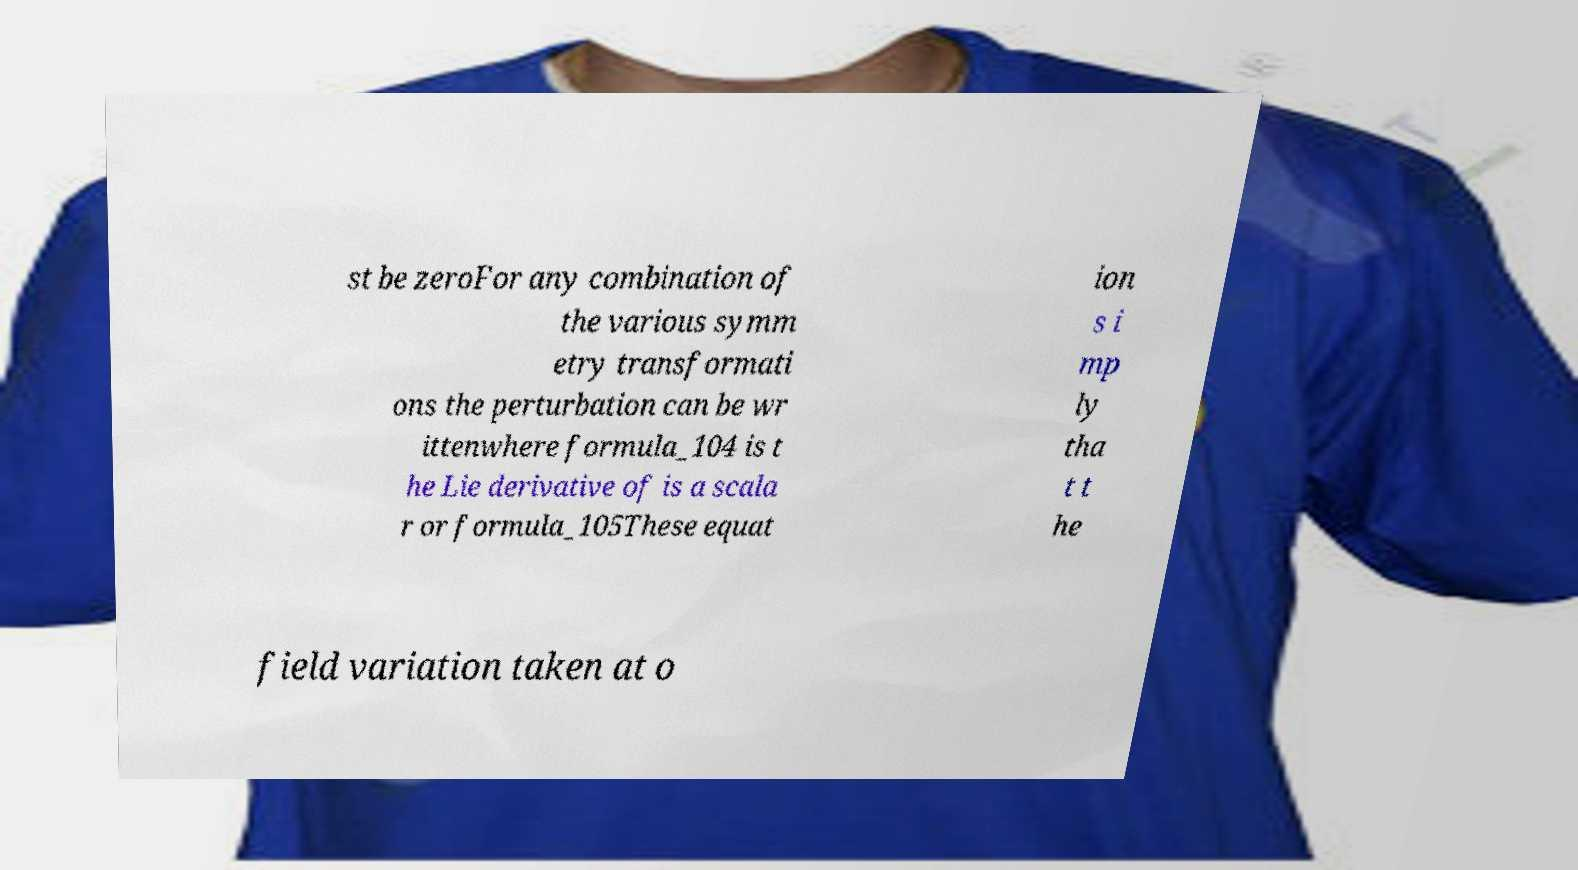Please identify and transcribe the text found in this image. st be zeroFor any combination of the various symm etry transformati ons the perturbation can be wr ittenwhere formula_104 is t he Lie derivative of is a scala r or formula_105These equat ion s i mp ly tha t t he field variation taken at o 